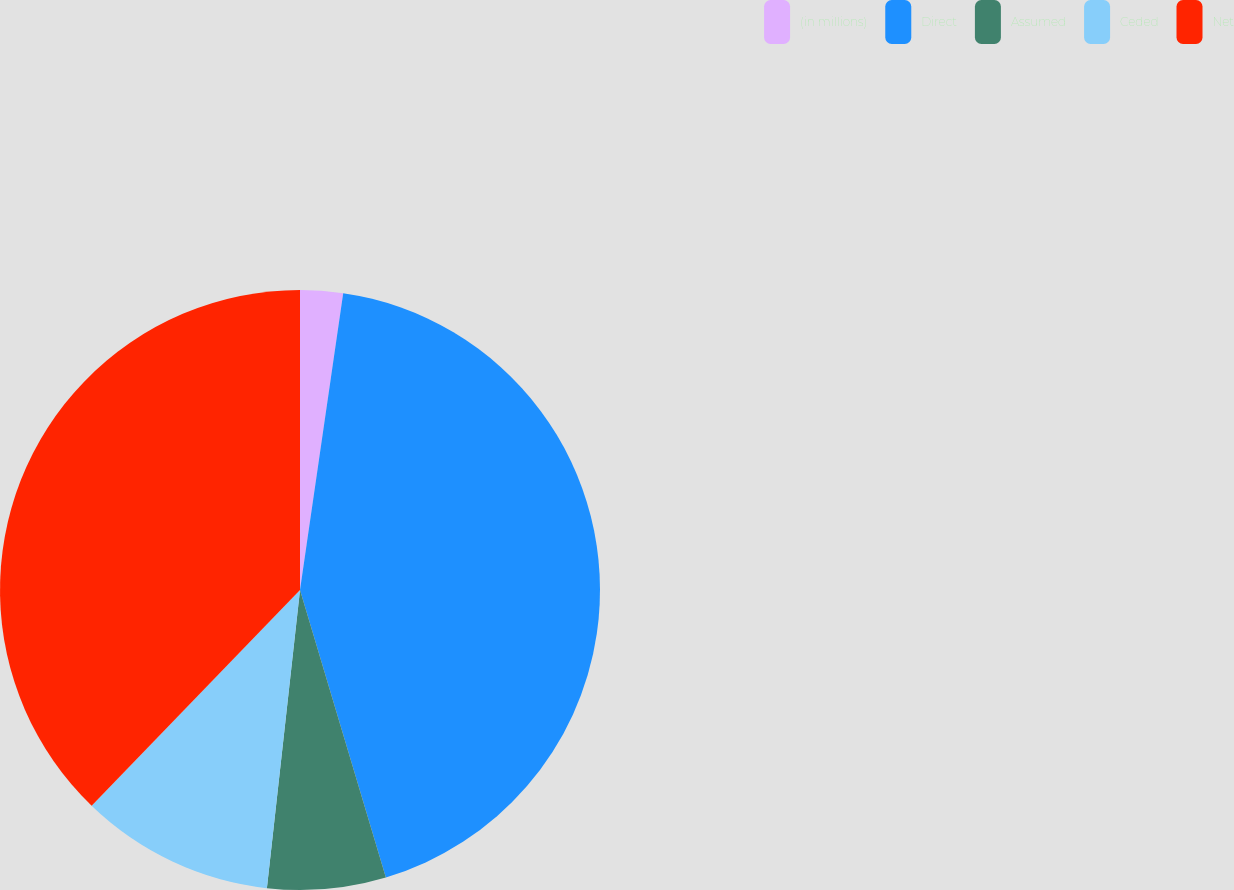<chart> <loc_0><loc_0><loc_500><loc_500><pie_chart><fcel>(in millions)<fcel>Direct<fcel>Assumed<fcel>Ceded<fcel>Net<nl><fcel>2.3%<fcel>43.08%<fcel>6.38%<fcel>10.46%<fcel>37.78%<nl></chart> 